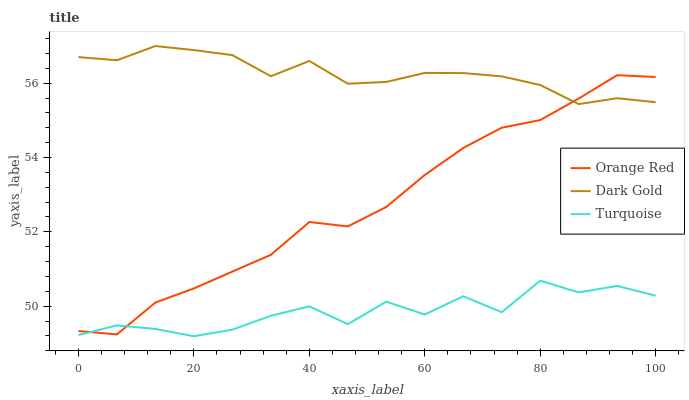Does Turquoise have the minimum area under the curve?
Answer yes or no. Yes. Does Dark Gold have the maximum area under the curve?
Answer yes or no. Yes. Does Orange Red have the minimum area under the curve?
Answer yes or no. No. Does Orange Red have the maximum area under the curve?
Answer yes or no. No. Is Orange Red the smoothest?
Answer yes or no. Yes. Is Turquoise the roughest?
Answer yes or no. Yes. Is Dark Gold the smoothest?
Answer yes or no. No. Is Dark Gold the roughest?
Answer yes or no. No. Does Turquoise have the lowest value?
Answer yes or no. Yes. Does Orange Red have the lowest value?
Answer yes or no. No. Does Dark Gold have the highest value?
Answer yes or no. Yes. Does Orange Red have the highest value?
Answer yes or no. No. Is Turquoise less than Dark Gold?
Answer yes or no. Yes. Is Dark Gold greater than Turquoise?
Answer yes or no. Yes. Does Orange Red intersect Dark Gold?
Answer yes or no. Yes. Is Orange Red less than Dark Gold?
Answer yes or no. No. Is Orange Red greater than Dark Gold?
Answer yes or no. No. Does Turquoise intersect Dark Gold?
Answer yes or no. No. 